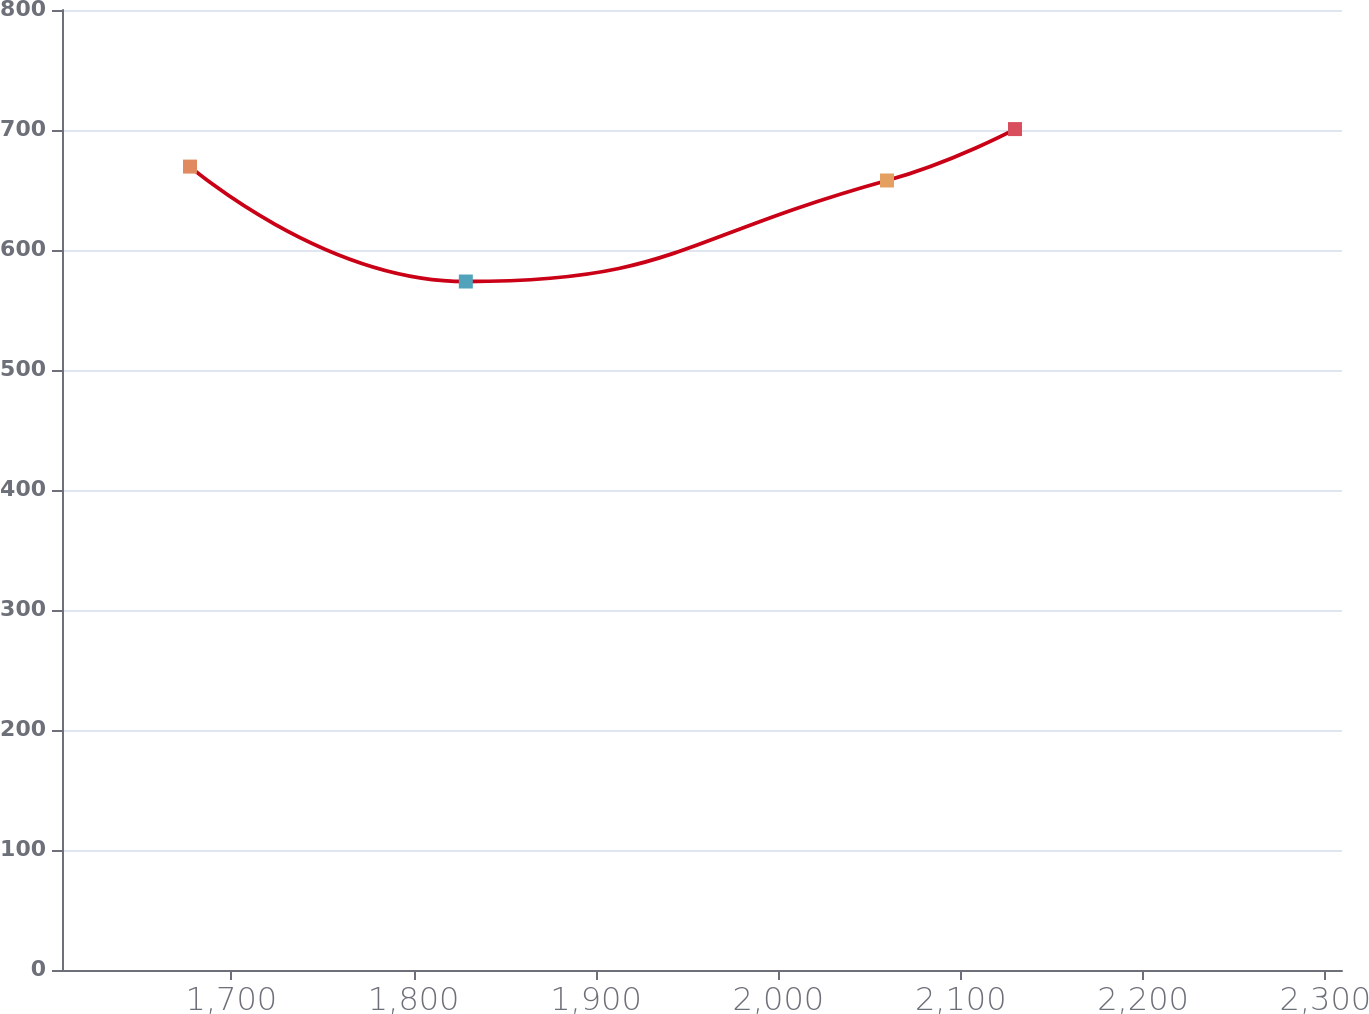<chart> <loc_0><loc_0><loc_500><loc_500><line_chart><ecel><fcel>Unnamed: 1<nl><fcel>1677.33<fcel>669.51<nl><fcel>1828.6<fcel>573.74<nl><fcel>2059.58<fcel>657.93<nl><fcel>2129.78<fcel>700.76<nl><fcel>2379.31<fcel>689.18<nl></chart> 